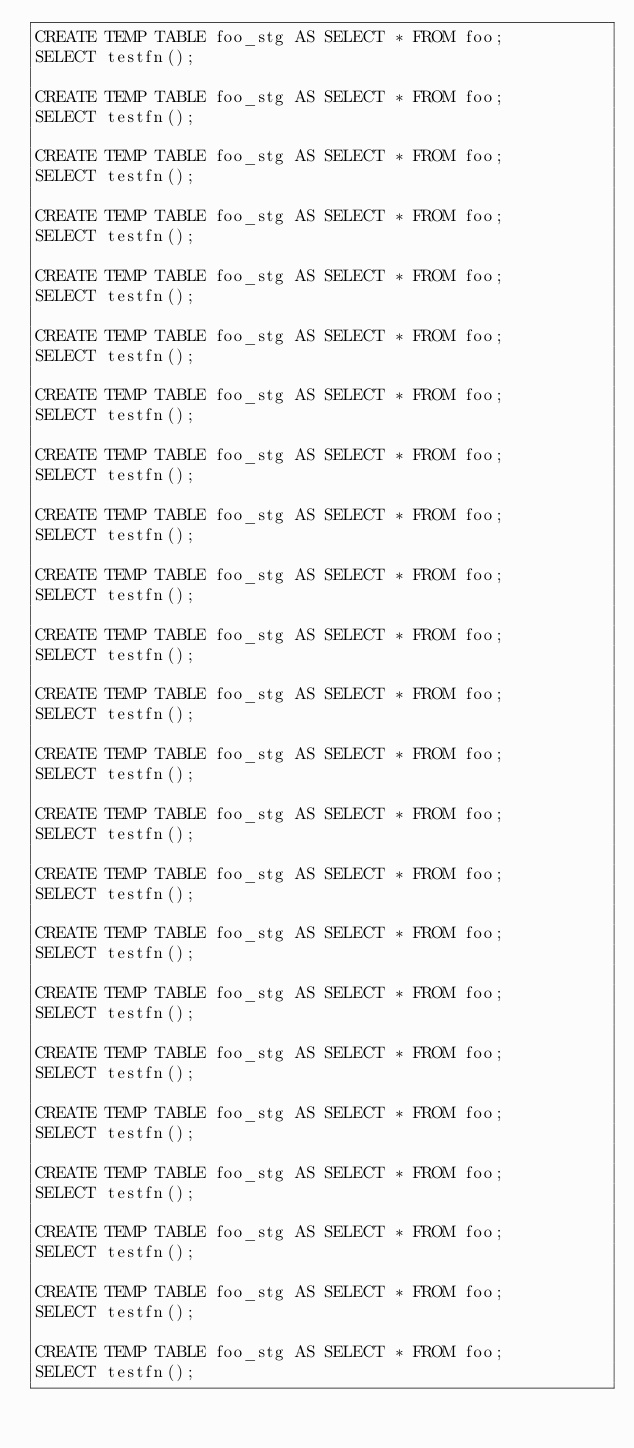<code> <loc_0><loc_0><loc_500><loc_500><_SQL_>CREATE TEMP TABLE foo_stg AS SELECT * FROM foo;
SELECT testfn();

CREATE TEMP TABLE foo_stg AS SELECT * FROM foo;
SELECT testfn();

CREATE TEMP TABLE foo_stg AS SELECT * FROM foo;
SELECT testfn();

CREATE TEMP TABLE foo_stg AS SELECT * FROM foo;
SELECT testfn();

CREATE TEMP TABLE foo_stg AS SELECT * FROM foo;
SELECT testfn();

CREATE TEMP TABLE foo_stg AS SELECT * FROM foo;
SELECT testfn();

CREATE TEMP TABLE foo_stg AS SELECT * FROM foo;
SELECT testfn();

CREATE TEMP TABLE foo_stg AS SELECT * FROM foo;
SELECT testfn();

CREATE TEMP TABLE foo_stg AS SELECT * FROM foo;
SELECT testfn();

CREATE TEMP TABLE foo_stg AS SELECT * FROM foo;
SELECT testfn();

CREATE TEMP TABLE foo_stg AS SELECT * FROM foo;
SELECT testfn();

CREATE TEMP TABLE foo_stg AS SELECT * FROM foo;
SELECT testfn();

CREATE TEMP TABLE foo_stg AS SELECT * FROM foo;
SELECT testfn();

CREATE TEMP TABLE foo_stg AS SELECT * FROM foo;
SELECT testfn();

CREATE TEMP TABLE foo_stg AS SELECT * FROM foo;
SELECT testfn();

CREATE TEMP TABLE foo_stg AS SELECT * FROM foo;
SELECT testfn();

CREATE TEMP TABLE foo_stg AS SELECT * FROM foo;
SELECT testfn();

CREATE TEMP TABLE foo_stg AS SELECT * FROM foo;
SELECT testfn();

CREATE TEMP TABLE foo_stg AS SELECT * FROM foo;
SELECT testfn();

CREATE TEMP TABLE foo_stg AS SELECT * FROM foo;
SELECT testfn();

CREATE TEMP TABLE foo_stg AS SELECT * FROM foo;
SELECT testfn();

CREATE TEMP TABLE foo_stg AS SELECT * FROM foo;
SELECT testfn();

CREATE TEMP TABLE foo_stg AS SELECT * FROM foo;
SELECT testfn();

</code> 